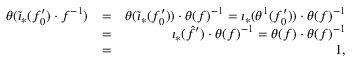Convert formula to latex. <formula><loc_0><loc_0><loc_500><loc_500>\begin{array} { r l r } { \theta ( \widetilde { \iota } _ { \ast } ( f _ { 0 } ^ { \prime } ) \cdot f ^ { - 1 } ) } & { = } & { \theta ( \widetilde { \iota } _ { \ast } ( f _ { 0 } ^ { \prime } ) ) \cdot \theta ( f ) ^ { - 1 } = \iota _ { \ast } ( \theta ^ { 1 } ( f _ { 0 } ^ { \prime } ) ) \cdot \theta ( f ) ^ { - 1 } } \\ & { = } & { \iota _ { \ast } ( \hat { f } ^ { \prime } ) \cdot \theta ( f ) ^ { - 1 } = \theta ( f ) \cdot \theta ( f ) ^ { - 1 } } \\ & { = } & { 1 , } \end{array}</formula> 